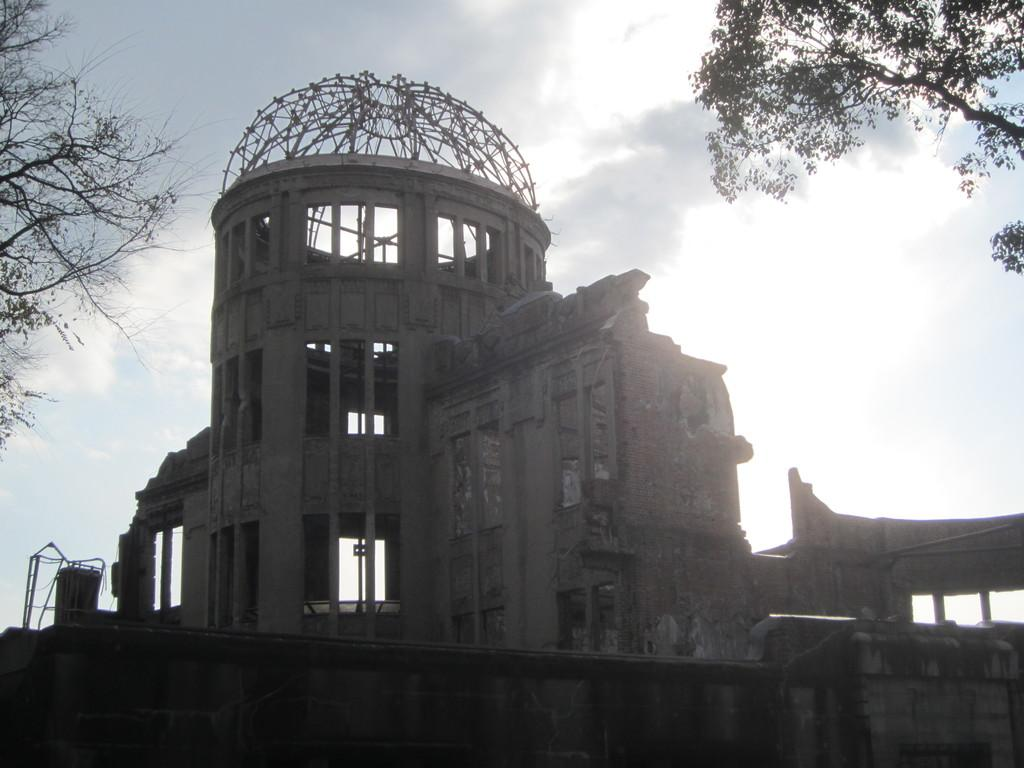What is the main subject in the center of the image? There are buildings in the center of the image. What can be seen in the top right side of the image? There are trees in the top right side of the image. What is present in the top left side of the image? There are trees in the top left side of the image. What type of neck accessory is worn by the aunt in the image? There is no aunt or neck accessory present in the image. What channel is the image taken from? The image is not taken from a channel; it is a still image. 